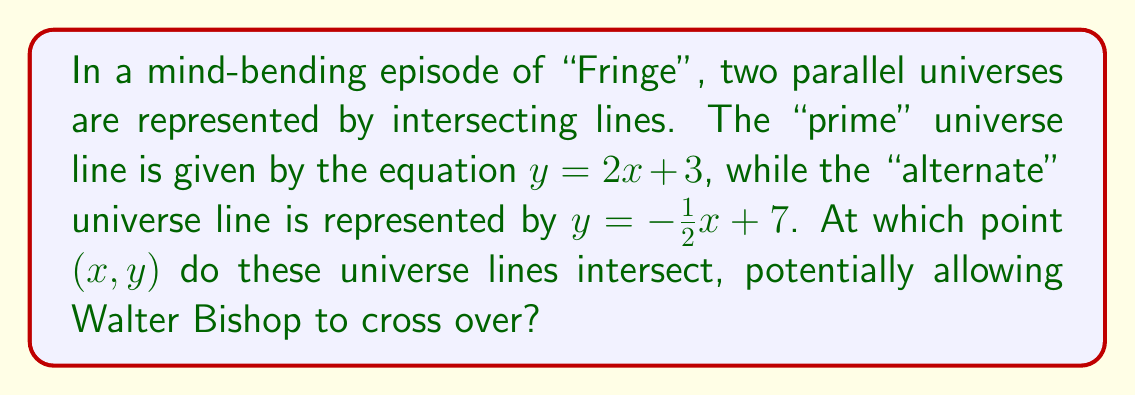What is the answer to this math problem? To find the intersection point of these two lines, we need to solve the system of equations:

1) $y = 2x + 3$ (prime universe)
2) $y = -\frac{1}{2}x + 7$ (alternate universe)

At the intersection point, the $y$ values will be equal. So we can set the right sides of these equations equal to each other:

$$2x + 3 = -\frac{1}{2}x + 7$$

Now, let's solve this equation for $x$:

1) Add $\frac{1}{2}x$ to both sides:
   $$2x + \frac{1}{2}x + 3 = 7$$
   $$\frac{5}{2}x + 3 = 7$$

2) Subtract 3 from both sides:
   $$\frac{5}{2}x = 4$$

3) Multiply both sides by $\frac{2}{5}$:
   $$x = \frac{8}{5} = 1.6$$

Now that we have $x$, we can substitute this value into either of the original equations to find $y$. Let's use the first equation:

$$y = 2x + 3$$
$$y = 2(1.6) + 3$$
$$y = 3.2 + 3 = 6.2$$

Therefore, the intersection point is $(1.6, 6.2)$.

[asy]
import graph;
size(200);
xaxis("x");
yaxis("y");
real f(real x) {return 2x + 3;}
real g(real x) {return -0.5x + 7;}
draw(graph(f,-1,3));
draw(graph(g,-1,5));
dot((1.6,6.2),red);
label("(1.6, 6.2)",(1.6,6.2),NE);
[/asy]
Answer: $(1.6, 6.2)$ 